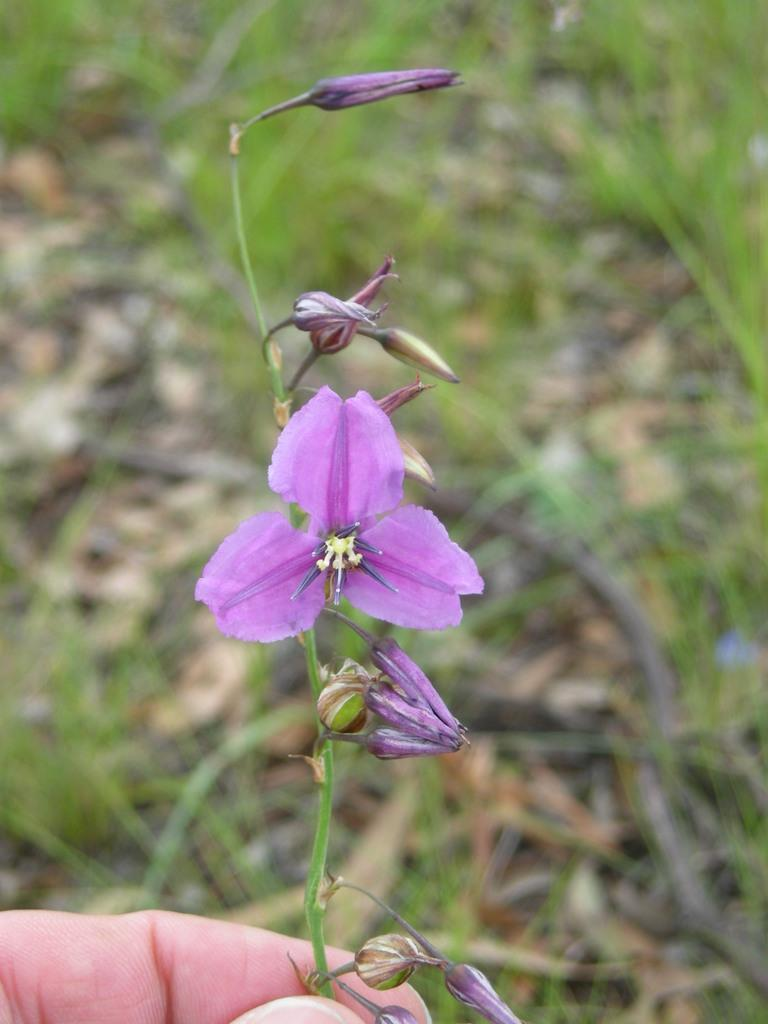What is the main subject of the image? The main subject of the image is the hand of a person. What is the hand holding? The hand is holding a plant. What can be observed about the plant? The plant has flowers. How would you describe the background of the image? The background of the image is blurred. What type of rod can be seen in the image? There is no rod present in the image. Is there a railway visible in the image? No, there is no railway visible in the image. 